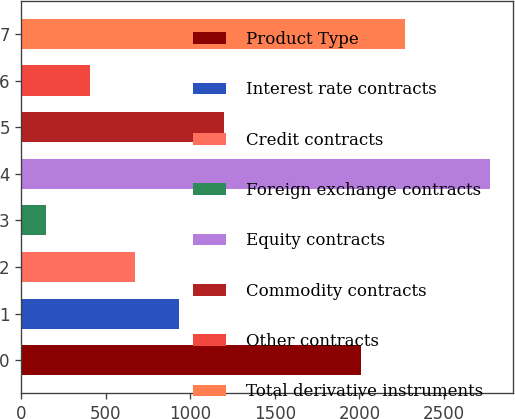<chart> <loc_0><loc_0><loc_500><loc_500><bar_chart><fcel>Product Type<fcel>Interest rate contracts<fcel>Credit contracts<fcel>Foreign exchange contracts<fcel>Equity contracts<fcel>Commodity contracts<fcel>Other contracts<fcel>Total derivative instruments<nl><fcel>2010<fcel>933.8<fcel>671.2<fcel>146<fcel>2772<fcel>1196.4<fcel>408.6<fcel>2272.6<nl></chart> 